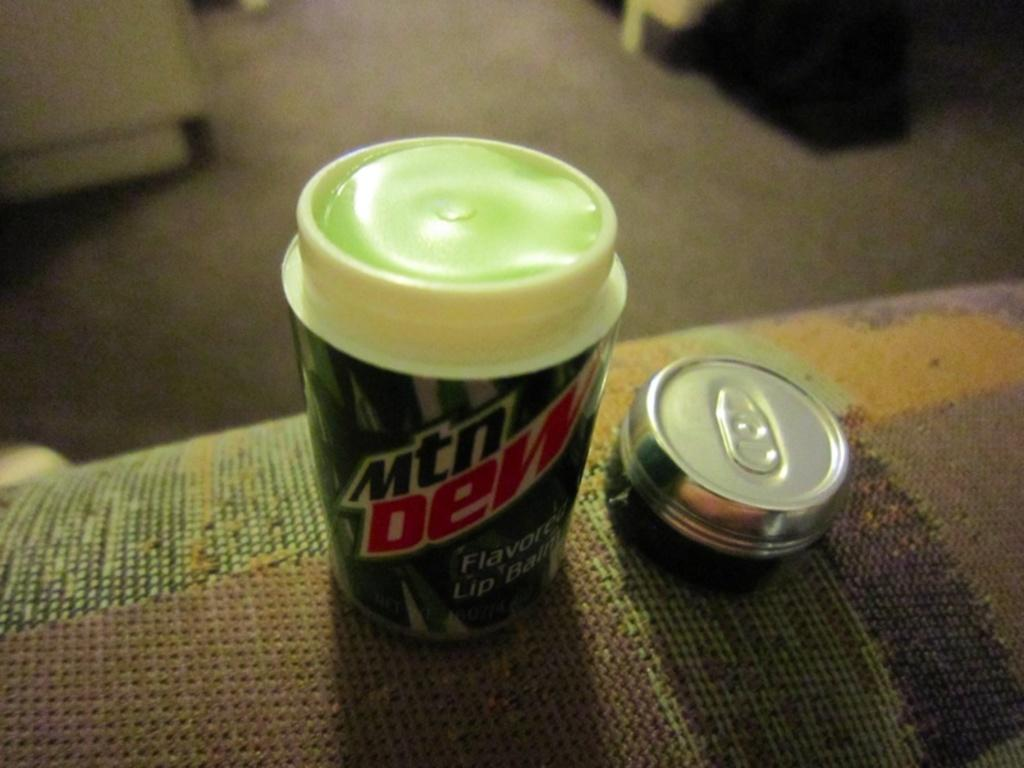<image>
Relay a brief, clear account of the picture shown. A mtn Dew has it's top sitting next to it on a sofa. 